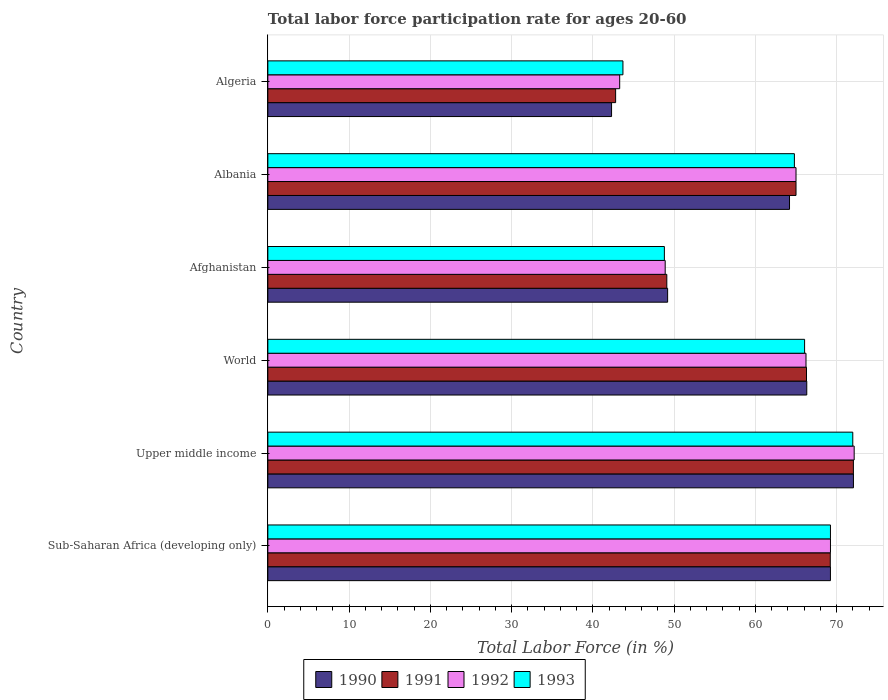How many bars are there on the 5th tick from the top?
Offer a very short reply. 4. How many bars are there on the 4th tick from the bottom?
Give a very brief answer. 4. In how many cases, is the number of bars for a given country not equal to the number of legend labels?
Your response must be concise. 0. What is the labor force participation rate in 1990 in World?
Ensure brevity in your answer.  66.32. Across all countries, what is the maximum labor force participation rate in 1993?
Your response must be concise. 71.98. Across all countries, what is the minimum labor force participation rate in 1991?
Ensure brevity in your answer.  42.8. In which country was the labor force participation rate in 1990 maximum?
Keep it short and to the point. Upper middle income. In which country was the labor force participation rate in 1990 minimum?
Your answer should be compact. Algeria. What is the total labor force participation rate in 1991 in the graph?
Provide a succinct answer. 364.47. What is the difference between the labor force participation rate in 1991 in Albania and that in Algeria?
Ensure brevity in your answer.  22.2. What is the difference between the labor force participation rate in 1992 in Albania and the labor force participation rate in 1993 in Afghanistan?
Ensure brevity in your answer.  16.2. What is the average labor force participation rate in 1993 per country?
Your answer should be very brief. 60.76. What is the difference between the labor force participation rate in 1990 and labor force participation rate in 1991 in Upper middle income?
Provide a short and direct response. 0.01. In how many countries, is the labor force participation rate in 1991 greater than 32 %?
Provide a succinct answer. 6. What is the ratio of the labor force participation rate in 1991 in Albania to that in Upper middle income?
Provide a short and direct response. 0.9. Is the difference between the labor force participation rate in 1990 in Sub-Saharan Africa (developing only) and World greater than the difference between the labor force participation rate in 1991 in Sub-Saharan Africa (developing only) and World?
Make the answer very short. No. What is the difference between the highest and the second highest labor force participation rate in 1993?
Provide a succinct answer. 2.75. What is the difference between the highest and the lowest labor force participation rate in 1990?
Ensure brevity in your answer.  29.77. Is it the case that in every country, the sum of the labor force participation rate in 1992 and labor force participation rate in 1990 is greater than the sum of labor force participation rate in 1993 and labor force participation rate in 1991?
Your answer should be compact. No. What does the 3rd bar from the bottom in World represents?
Your answer should be very brief. 1992. Is it the case that in every country, the sum of the labor force participation rate in 1990 and labor force participation rate in 1993 is greater than the labor force participation rate in 1992?
Offer a terse response. Yes. Are all the bars in the graph horizontal?
Provide a succinct answer. Yes. What is the difference between two consecutive major ticks on the X-axis?
Offer a very short reply. 10. Does the graph contain any zero values?
Offer a very short reply. No. Where does the legend appear in the graph?
Give a very brief answer. Bottom center. What is the title of the graph?
Your answer should be very brief. Total labor force participation rate for ages 20-60. What is the label or title of the X-axis?
Offer a very short reply. Total Labor Force (in %). What is the Total Labor Force (in %) in 1990 in Sub-Saharan Africa (developing only)?
Keep it short and to the point. 69.24. What is the Total Labor Force (in %) of 1991 in Sub-Saharan Africa (developing only)?
Give a very brief answer. 69.22. What is the Total Labor Force (in %) of 1992 in Sub-Saharan Africa (developing only)?
Keep it short and to the point. 69.24. What is the Total Labor Force (in %) of 1993 in Sub-Saharan Africa (developing only)?
Your answer should be very brief. 69.24. What is the Total Labor Force (in %) of 1990 in Upper middle income?
Give a very brief answer. 72.07. What is the Total Labor Force (in %) of 1991 in Upper middle income?
Give a very brief answer. 72.06. What is the Total Labor Force (in %) in 1992 in Upper middle income?
Offer a very short reply. 72.16. What is the Total Labor Force (in %) of 1993 in Upper middle income?
Ensure brevity in your answer.  71.98. What is the Total Labor Force (in %) of 1990 in World?
Your answer should be very brief. 66.32. What is the Total Labor Force (in %) in 1991 in World?
Provide a short and direct response. 66.29. What is the Total Labor Force (in %) of 1992 in World?
Your response must be concise. 66.23. What is the Total Labor Force (in %) in 1993 in World?
Your answer should be compact. 66.06. What is the Total Labor Force (in %) of 1990 in Afghanistan?
Offer a terse response. 49.2. What is the Total Labor Force (in %) of 1991 in Afghanistan?
Keep it short and to the point. 49.1. What is the Total Labor Force (in %) in 1992 in Afghanistan?
Offer a terse response. 48.9. What is the Total Labor Force (in %) of 1993 in Afghanistan?
Ensure brevity in your answer.  48.8. What is the Total Labor Force (in %) of 1990 in Albania?
Give a very brief answer. 64.2. What is the Total Labor Force (in %) in 1992 in Albania?
Offer a terse response. 65. What is the Total Labor Force (in %) of 1993 in Albania?
Offer a terse response. 64.8. What is the Total Labor Force (in %) of 1990 in Algeria?
Ensure brevity in your answer.  42.3. What is the Total Labor Force (in %) in 1991 in Algeria?
Ensure brevity in your answer.  42.8. What is the Total Labor Force (in %) in 1992 in Algeria?
Ensure brevity in your answer.  43.3. What is the Total Labor Force (in %) in 1993 in Algeria?
Offer a very short reply. 43.7. Across all countries, what is the maximum Total Labor Force (in %) in 1990?
Keep it short and to the point. 72.07. Across all countries, what is the maximum Total Labor Force (in %) in 1991?
Keep it short and to the point. 72.06. Across all countries, what is the maximum Total Labor Force (in %) of 1992?
Your response must be concise. 72.16. Across all countries, what is the maximum Total Labor Force (in %) in 1993?
Offer a very short reply. 71.98. Across all countries, what is the minimum Total Labor Force (in %) in 1990?
Ensure brevity in your answer.  42.3. Across all countries, what is the minimum Total Labor Force (in %) in 1991?
Offer a very short reply. 42.8. Across all countries, what is the minimum Total Labor Force (in %) in 1992?
Offer a very short reply. 43.3. Across all countries, what is the minimum Total Labor Force (in %) in 1993?
Make the answer very short. 43.7. What is the total Total Labor Force (in %) of 1990 in the graph?
Offer a very short reply. 363.33. What is the total Total Labor Force (in %) in 1991 in the graph?
Your answer should be compact. 364.47. What is the total Total Labor Force (in %) of 1992 in the graph?
Your response must be concise. 364.82. What is the total Total Labor Force (in %) of 1993 in the graph?
Ensure brevity in your answer.  364.58. What is the difference between the Total Labor Force (in %) of 1990 in Sub-Saharan Africa (developing only) and that in Upper middle income?
Your response must be concise. -2.83. What is the difference between the Total Labor Force (in %) in 1991 in Sub-Saharan Africa (developing only) and that in Upper middle income?
Offer a terse response. -2.84. What is the difference between the Total Labor Force (in %) in 1992 in Sub-Saharan Africa (developing only) and that in Upper middle income?
Ensure brevity in your answer.  -2.92. What is the difference between the Total Labor Force (in %) in 1993 in Sub-Saharan Africa (developing only) and that in Upper middle income?
Your answer should be very brief. -2.75. What is the difference between the Total Labor Force (in %) of 1990 in Sub-Saharan Africa (developing only) and that in World?
Offer a terse response. 2.91. What is the difference between the Total Labor Force (in %) in 1991 in Sub-Saharan Africa (developing only) and that in World?
Your response must be concise. 2.93. What is the difference between the Total Labor Force (in %) of 1992 in Sub-Saharan Africa (developing only) and that in World?
Give a very brief answer. 3.01. What is the difference between the Total Labor Force (in %) in 1993 in Sub-Saharan Africa (developing only) and that in World?
Offer a very short reply. 3.18. What is the difference between the Total Labor Force (in %) of 1990 in Sub-Saharan Africa (developing only) and that in Afghanistan?
Offer a terse response. 20.04. What is the difference between the Total Labor Force (in %) of 1991 in Sub-Saharan Africa (developing only) and that in Afghanistan?
Give a very brief answer. 20.12. What is the difference between the Total Labor Force (in %) in 1992 in Sub-Saharan Africa (developing only) and that in Afghanistan?
Offer a very short reply. 20.34. What is the difference between the Total Labor Force (in %) of 1993 in Sub-Saharan Africa (developing only) and that in Afghanistan?
Keep it short and to the point. 20.44. What is the difference between the Total Labor Force (in %) in 1990 in Sub-Saharan Africa (developing only) and that in Albania?
Give a very brief answer. 5.04. What is the difference between the Total Labor Force (in %) in 1991 in Sub-Saharan Africa (developing only) and that in Albania?
Ensure brevity in your answer.  4.22. What is the difference between the Total Labor Force (in %) of 1992 in Sub-Saharan Africa (developing only) and that in Albania?
Your answer should be compact. 4.24. What is the difference between the Total Labor Force (in %) in 1993 in Sub-Saharan Africa (developing only) and that in Albania?
Provide a succinct answer. 4.44. What is the difference between the Total Labor Force (in %) of 1990 in Sub-Saharan Africa (developing only) and that in Algeria?
Provide a short and direct response. 26.94. What is the difference between the Total Labor Force (in %) in 1991 in Sub-Saharan Africa (developing only) and that in Algeria?
Give a very brief answer. 26.42. What is the difference between the Total Labor Force (in %) in 1992 in Sub-Saharan Africa (developing only) and that in Algeria?
Ensure brevity in your answer.  25.94. What is the difference between the Total Labor Force (in %) of 1993 in Sub-Saharan Africa (developing only) and that in Algeria?
Offer a terse response. 25.54. What is the difference between the Total Labor Force (in %) of 1990 in Upper middle income and that in World?
Ensure brevity in your answer.  5.74. What is the difference between the Total Labor Force (in %) in 1991 in Upper middle income and that in World?
Your answer should be compact. 5.77. What is the difference between the Total Labor Force (in %) in 1992 in Upper middle income and that in World?
Your answer should be compact. 5.93. What is the difference between the Total Labor Force (in %) in 1993 in Upper middle income and that in World?
Your answer should be very brief. 5.93. What is the difference between the Total Labor Force (in %) in 1990 in Upper middle income and that in Afghanistan?
Your answer should be compact. 22.87. What is the difference between the Total Labor Force (in %) in 1991 in Upper middle income and that in Afghanistan?
Your response must be concise. 22.96. What is the difference between the Total Labor Force (in %) of 1992 in Upper middle income and that in Afghanistan?
Keep it short and to the point. 23.26. What is the difference between the Total Labor Force (in %) of 1993 in Upper middle income and that in Afghanistan?
Ensure brevity in your answer.  23.18. What is the difference between the Total Labor Force (in %) in 1990 in Upper middle income and that in Albania?
Your response must be concise. 7.87. What is the difference between the Total Labor Force (in %) of 1991 in Upper middle income and that in Albania?
Offer a terse response. 7.06. What is the difference between the Total Labor Force (in %) in 1992 in Upper middle income and that in Albania?
Make the answer very short. 7.16. What is the difference between the Total Labor Force (in %) in 1993 in Upper middle income and that in Albania?
Offer a terse response. 7.18. What is the difference between the Total Labor Force (in %) in 1990 in Upper middle income and that in Algeria?
Keep it short and to the point. 29.77. What is the difference between the Total Labor Force (in %) in 1991 in Upper middle income and that in Algeria?
Offer a very short reply. 29.26. What is the difference between the Total Labor Force (in %) in 1992 in Upper middle income and that in Algeria?
Your response must be concise. 28.86. What is the difference between the Total Labor Force (in %) of 1993 in Upper middle income and that in Algeria?
Provide a short and direct response. 28.28. What is the difference between the Total Labor Force (in %) of 1990 in World and that in Afghanistan?
Provide a succinct answer. 17.12. What is the difference between the Total Labor Force (in %) of 1991 in World and that in Afghanistan?
Provide a short and direct response. 17.19. What is the difference between the Total Labor Force (in %) in 1992 in World and that in Afghanistan?
Provide a succinct answer. 17.33. What is the difference between the Total Labor Force (in %) in 1993 in World and that in Afghanistan?
Make the answer very short. 17.26. What is the difference between the Total Labor Force (in %) in 1990 in World and that in Albania?
Your response must be concise. 2.12. What is the difference between the Total Labor Force (in %) of 1991 in World and that in Albania?
Offer a very short reply. 1.29. What is the difference between the Total Labor Force (in %) in 1992 in World and that in Albania?
Keep it short and to the point. 1.23. What is the difference between the Total Labor Force (in %) in 1993 in World and that in Albania?
Ensure brevity in your answer.  1.26. What is the difference between the Total Labor Force (in %) of 1990 in World and that in Algeria?
Make the answer very short. 24.02. What is the difference between the Total Labor Force (in %) in 1991 in World and that in Algeria?
Your answer should be very brief. 23.49. What is the difference between the Total Labor Force (in %) in 1992 in World and that in Algeria?
Offer a very short reply. 22.93. What is the difference between the Total Labor Force (in %) of 1993 in World and that in Algeria?
Your answer should be very brief. 22.36. What is the difference between the Total Labor Force (in %) in 1991 in Afghanistan and that in Albania?
Your answer should be compact. -15.9. What is the difference between the Total Labor Force (in %) in 1992 in Afghanistan and that in Albania?
Offer a terse response. -16.1. What is the difference between the Total Labor Force (in %) in 1990 in Afghanistan and that in Algeria?
Offer a very short reply. 6.9. What is the difference between the Total Labor Force (in %) of 1992 in Afghanistan and that in Algeria?
Your response must be concise. 5.6. What is the difference between the Total Labor Force (in %) of 1993 in Afghanistan and that in Algeria?
Provide a succinct answer. 5.1. What is the difference between the Total Labor Force (in %) of 1990 in Albania and that in Algeria?
Your answer should be compact. 21.9. What is the difference between the Total Labor Force (in %) of 1991 in Albania and that in Algeria?
Provide a succinct answer. 22.2. What is the difference between the Total Labor Force (in %) of 1992 in Albania and that in Algeria?
Offer a terse response. 21.7. What is the difference between the Total Labor Force (in %) in 1993 in Albania and that in Algeria?
Your answer should be compact. 21.1. What is the difference between the Total Labor Force (in %) of 1990 in Sub-Saharan Africa (developing only) and the Total Labor Force (in %) of 1991 in Upper middle income?
Your response must be concise. -2.82. What is the difference between the Total Labor Force (in %) in 1990 in Sub-Saharan Africa (developing only) and the Total Labor Force (in %) in 1992 in Upper middle income?
Ensure brevity in your answer.  -2.92. What is the difference between the Total Labor Force (in %) in 1990 in Sub-Saharan Africa (developing only) and the Total Labor Force (in %) in 1993 in Upper middle income?
Make the answer very short. -2.75. What is the difference between the Total Labor Force (in %) in 1991 in Sub-Saharan Africa (developing only) and the Total Labor Force (in %) in 1992 in Upper middle income?
Your answer should be compact. -2.94. What is the difference between the Total Labor Force (in %) in 1991 in Sub-Saharan Africa (developing only) and the Total Labor Force (in %) in 1993 in Upper middle income?
Offer a terse response. -2.77. What is the difference between the Total Labor Force (in %) of 1992 in Sub-Saharan Africa (developing only) and the Total Labor Force (in %) of 1993 in Upper middle income?
Your response must be concise. -2.75. What is the difference between the Total Labor Force (in %) of 1990 in Sub-Saharan Africa (developing only) and the Total Labor Force (in %) of 1991 in World?
Ensure brevity in your answer.  2.95. What is the difference between the Total Labor Force (in %) in 1990 in Sub-Saharan Africa (developing only) and the Total Labor Force (in %) in 1992 in World?
Keep it short and to the point. 3.01. What is the difference between the Total Labor Force (in %) in 1990 in Sub-Saharan Africa (developing only) and the Total Labor Force (in %) in 1993 in World?
Your answer should be compact. 3.18. What is the difference between the Total Labor Force (in %) of 1991 in Sub-Saharan Africa (developing only) and the Total Labor Force (in %) of 1992 in World?
Offer a very short reply. 2.99. What is the difference between the Total Labor Force (in %) of 1991 in Sub-Saharan Africa (developing only) and the Total Labor Force (in %) of 1993 in World?
Offer a very short reply. 3.16. What is the difference between the Total Labor Force (in %) of 1992 in Sub-Saharan Africa (developing only) and the Total Labor Force (in %) of 1993 in World?
Give a very brief answer. 3.18. What is the difference between the Total Labor Force (in %) of 1990 in Sub-Saharan Africa (developing only) and the Total Labor Force (in %) of 1991 in Afghanistan?
Your answer should be compact. 20.14. What is the difference between the Total Labor Force (in %) of 1990 in Sub-Saharan Africa (developing only) and the Total Labor Force (in %) of 1992 in Afghanistan?
Your response must be concise. 20.34. What is the difference between the Total Labor Force (in %) of 1990 in Sub-Saharan Africa (developing only) and the Total Labor Force (in %) of 1993 in Afghanistan?
Give a very brief answer. 20.44. What is the difference between the Total Labor Force (in %) in 1991 in Sub-Saharan Africa (developing only) and the Total Labor Force (in %) in 1992 in Afghanistan?
Offer a very short reply. 20.32. What is the difference between the Total Labor Force (in %) of 1991 in Sub-Saharan Africa (developing only) and the Total Labor Force (in %) of 1993 in Afghanistan?
Your answer should be compact. 20.42. What is the difference between the Total Labor Force (in %) in 1992 in Sub-Saharan Africa (developing only) and the Total Labor Force (in %) in 1993 in Afghanistan?
Offer a terse response. 20.44. What is the difference between the Total Labor Force (in %) of 1990 in Sub-Saharan Africa (developing only) and the Total Labor Force (in %) of 1991 in Albania?
Provide a succinct answer. 4.24. What is the difference between the Total Labor Force (in %) in 1990 in Sub-Saharan Africa (developing only) and the Total Labor Force (in %) in 1992 in Albania?
Keep it short and to the point. 4.24. What is the difference between the Total Labor Force (in %) in 1990 in Sub-Saharan Africa (developing only) and the Total Labor Force (in %) in 1993 in Albania?
Ensure brevity in your answer.  4.44. What is the difference between the Total Labor Force (in %) in 1991 in Sub-Saharan Africa (developing only) and the Total Labor Force (in %) in 1992 in Albania?
Make the answer very short. 4.22. What is the difference between the Total Labor Force (in %) in 1991 in Sub-Saharan Africa (developing only) and the Total Labor Force (in %) in 1993 in Albania?
Provide a short and direct response. 4.42. What is the difference between the Total Labor Force (in %) of 1992 in Sub-Saharan Africa (developing only) and the Total Labor Force (in %) of 1993 in Albania?
Offer a very short reply. 4.44. What is the difference between the Total Labor Force (in %) of 1990 in Sub-Saharan Africa (developing only) and the Total Labor Force (in %) of 1991 in Algeria?
Make the answer very short. 26.44. What is the difference between the Total Labor Force (in %) in 1990 in Sub-Saharan Africa (developing only) and the Total Labor Force (in %) in 1992 in Algeria?
Your answer should be very brief. 25.94. What is the difference between the Total Labor Force (in %) in 1990 in Sub-Saharan Africa (developing only) and the Total Labor Force (in %) in 1993 in Algeria?
Your answer should be very brief. 25.54. What is the difference between the Total Labor Force (in %) in 1991 in Sub-Saharan Africa (developing only) and the Total Labor Force (in %) in 1992 in Algeria?
Keep it short and to the point. 25.92. What is the difference between the Total Labor Force (in %) in 1991 in Sub-Saharan Africa (developing only) and the Total Labor Force (in %) in 1993 in Algeria?
Your answer should be very brief. 25.52. What is the difference between the Total Labor Force (in %) of 1992 in Sub-Saharan Africa (developing only) and the Total Labor Force (in %) of 1993 in Algeria?
Give a very brief answer. 25.54. What is the difference between the Total Labor Force (in %) of 1990 in Upper middle income and the Total Labor Force (in %) of 1991 in World?
Provide a short and direct response. 5.78. What is the difference between the Total Labor Force (in %) in 1990 in Upper middle income and the Total Labor Force (in %) in 1992 in World?
Give a very brief answer. 5.84. What is the difference between the Total Labor Force (in %) in 1990 in Upper middle income and the Total Labor Force (in %) in 1993 in World?
Make the answer very short. 6.01. What is the difference between the Total Labor Force (in %) of 1991 in Upper middle income and the Total Labor Force (in %) of 1992 in World?
Give a very brief answer. 5.83. What is the difference between the Total Labor Force (in %) of 1991 in Upper middle income and the Total Labor Force (in %) of 1993 in World?
Your answer should be compact. 6. What is the difference between the Total Labor Force (in %) of 1992 in Upper middle income and the Total Labor Force (in %) of 1993 in World?
Offer a terse response. 6.1. What is the difference between the Total Labor Force (in %) of 1990 in Upper middle income and the Total Labor Force (in %) of 1991 in Afghanistan?
Provide a short and direct response. 22.97. What is the difference between the Total Labor Force (in %) of 1990 in Upper middle income and the Total Labor Force (in %) of 1992 in Afghanistan?
Your answer should be very brief. 23.17. What is the difference between the Total Labor Force (in %) of 1990 in Upper middle income and the Total Labor Force (in %) of 1993 in Afghanistan?
Keep it short and to the point. 23.27. What is the difference between the Total Labor Force (in %) in 1991 in Upper middle income and the Total Labor Force (in %) in 1992 in Afghanistan?
Make the answer very short. 23.16. What is the difference between the Total Labor Force (in %) of 1991 in Upper middle income and the Total Labor Force (in %) of 1993 in Afghanistan?
Your answer should be very brief. 23.26. What is the difference between the Total Labor Force (in %) of 1992 in Upper middle income and the Total Labor Force (in %) of 1993 in Afghanistan?
Give a very brief answer. 23.36. What is the difference between the Total Labor Force (in %) in 1990 in Upper middle income and the Total Labor Force (in %) in 1991 in Albania?
Your answer should be compact. 7.07. What is the difference between the Total Labor Force (in %) of 1990 in Upper middle income and the Total Labor Force (in %) of 1992 in Albania?
Offer a very short reply. 7.07. What is the difference between the Total Labor Force (in %) of 1990 in Upper middle income and the Total Labor Force (in %) of 1993 in Albania?
Your answer should be compact. 7.27. What is the difference between the Total Labor Force (in %) in 1991 in Upper middle income and the Total Labor Force (in %) in 1992 in Albania?
Ensure brevity in your answer.  7.06. What is the difference between the Total Labor Force (in %) in 1991 in Upper middle income and the Total Labor Force (in %) in 1993 in Albania?
Ensure brevity in your answer.  7.26. What is the difference between the Total Labor Force (in %) of 1992 in Upper middle income and the Total Labor Force (in %) of 1993 in Albania?
Your response must be concise. 7.36. What is the difference between the Total Labor Force (in %) of 1990 in Upper middle income and the Total Labor Force (in %) of 1991 in Algeria?
Make the answer very short. 29.27. What is the difference between the Total Labor Force (in %) in 1990 in Upper middle income and the Total Labor Force (in %) in 1992 in Algeria?
Keep it short and to the point. 28.77. What is the difference between the Total Labor Force (in %) of 1990 in Upper middle income and the Total Labor Force (in %) of 1993 in Algeria?
Offer a terse response. 28.37. What is the difference between the Total Labor Force (in %) in 1991 in Upper middle income and the Total Labor Force (in %) in 1992 in Algeria?
Your answer should be very brief. 28.76. What is the difference between the Total Labor Force (in %) in 1991 in Upper middle income and the Total Labor Force (in %) in 1993 in Algeria?
Offer a terse response. 28.36. What is the difference between the Total Labor Force (in %) of 1992 in Upper middle income and the Total Labor Force (in %) of 1993 in Algeria?
Keep it short and to the point. 28.46. What is the difference between the Total Labor Force (in %) in 1990 in World and the Total Labor Force (in %) in 1991 in Afghanistan?
Give a very brief answer. 17.22. What is the difference between the Total Labor Force (in %) in 1990 in World and the Total Labor Force (in %) in 1992 in Afghanistan?
Your answer should be compact. 17.42. What is the difference between the Total Labor Force (in %) in 1990 in World and the Total Labor Force (in %) in 1993 in Afghanistan?
Provide a short and direct response. 17.52. What is the difference between the Total Labor Force (in %) of 1991 in World and the Total Labor Force (in %) of 1992 in Afghanistan?
Give a very brief answer. 17.39. What is the difference between the Total Labor Force (in %) in 1991 in World and the Total Labor Force (in %) in 1993 in Afghanistan?
Offer a very short reply. 17.49. What is the difference between the Total Labor Force (in %) of 1992 in World and the Total Labor Force (in %) of 1993 in Afghanistan?
Your response must be concise. 17.43. What is the difference between the Total Labor Force (in %) of 1990 in World and the Total Labor Force (in %) of 1991 in Albania?
Offer a terse response. 1.32. What is the difference between the Total Labor Force (in %) in 1990 in World and the Total Labor Force (in %) in 1992 in Albania?
Provide a short and direct response. 1.32. What is the difference between the Total Labor Force (in %) in 1990 in World and the Total Labor Force (in %) in 1993 in Albania?
Offer a terse response. 1.52. What is the difference between the Total Labor Force (in %) in 1991 in World and the Total Labor Force (in %) in 1992 in Albania?
Offer a terse response. 1.29. What is the difference between the Total Labor Force (in %) in 1991 in World and the Total Labor Force (in %) in 1993 in Albania?
Make the answer very short. 1.49. What is the difference between the Total Labor Force (in %) in 1992 in World and the Total Labor Force (in %) in 1993 in Albania?
Keep it short and to the point. 1.43. What is the difference between the Total Labor Force (in %) in 1990 in World and the Total Labor Force (in %) in 1991 in Algeria?
Offer a terse response. 23.52. What is the difference between the Total Labor Force (in %) in 1990 in World and the Total Labor Force (in %) in 1992 in Algeria?
Provide a succinct answer. 23.02. What is the difference between the Total Labor Force (in %) in 1990 in World and the Total Labor Force (in %) in 1993 in Algeria?
Provide a succinct answer. 22.62. What is the difference between the Total Labor Force (in %) in 1991 in World and the Total Labor Force (in %) in 1992 in Algeria?
Provide a succinct answer. 22.99. What is the difference between the Total Labor Force (in %) in 1991 in World and the Total Labor Force (in %) in 1993 in Algeria?
Provide a succinct answer. 22.59. What is the difference between the Total Labor Force (in %) in 1992 in World and the Total Labor Force (in %) in 1993 in Algeria?
Give a very brief answer. 22.53. What is the difference between the Total Labor Force (in %) of 1990 in Afghanistan and the Total Labor Force (in %) of 1991 in Albania?
Give a very brief answer. -15.8. What is the difference between the Total Labor Force (in %) in 1990 in Afghanistan and the Total Labor Force (in %) in 1992 in Albania?
Make the answer very short. -15.8. What is the difference between the Total Labor Force (in %) of 1990 in Afghanistan and the Total Labor Force (in %) of 1993 in Albania?
Offer a terse response. -15.6. What is the difference between the Total Labor Force (in %) in 1991 in Afghanistan and the Total Labor Force (in %) in 1992 in Albania?
Ensure brevity in your answer.  -15.9. What is the difference between the Total Labor Force (in %) of 1991 in Afghanistan and the Total Labor Force (in %) of 1993 in Albania?
Provide a short and direct response. -15.7. What is the difference between the Total Labor Force (in %) of 1992 in Afghanistan and the Total Labor Force (in %) of 1993 in Albania?
Keep it short and to the point. -15.9. What is the difference between the Total Labor Force (in %) in 1990 in Afghanistan and the Total Labor Force (in %) in 1993 in Algeria?
Keep it short and to the point. 5.5. What is the difference between the Total Labor Force (in %) in 1990 in Albania and the Total Labor Force (in %) in 1991 in Algeria?
Offer a terse response. 21.4. What is the difference between the Total Labor Force (in %) of 1990 in Albania and the Total Labor Force (in %) of 1992 in Algeria?
Your answer should be very brief. 20.9. What is the difference between the Total Labor Force (in %) of 1990 in Albania and the Total Labor Force (in %) of 1993 in Algeria?
Your answer should be compact. 20.5. What is the difference between the Total Labor Force (in %) of 1991 in Albania and the Total Labor Force (in %) of 1992 in Algeria?
Offer a terse response. 21.7. What is the difference between the Total Labor Force (in %) in 1991 in Albania and the Total Labor Force (in %) in 1993 in Algeria?
Offer a terse response. 21.3. What is the difference between the Total Labor Force (in %) of 1992 in Albania and the Total Labor Force (in %) of 1993 in Algeria?
Your answer should be compact. 21.3. What is the average Total Labor Force (in %) of 1990 per country?
Offer a terse response. 60.55. What is the average Total Labor Force (in %) in 1991 per country?
Your answer should be very brief. 60.74. What is the average Total Labor Force (in %) in 1992 per country?
Your answer should be very brief. 60.8. What is the average Total Labor Force (in %) of 1993 per country?
Ensure brevity in your answer.  60.76. What is the difference between the Total Labor Force (in %) in 1990 and Total Labor Force (in %) in 1991 in Sub-Saharan Africa (developing only)?
Provide a succinct answer. 0.02. What is the difference between the Total Labor Force (in %) of 1990 and Total Labor Force (in %) of 1992 in Sub-Saharan Africa (developing only)?
Your answer should be very brief. -0. What is the difference between the Total Labor Force (in %) of 1990 and Total Labor Force (in %) of 1993 in Sub-Saharan Africa (developing only)?
Offer a very short reply. -0. What is the difference between the Total Labor Force (in %) in 1991 and Total Labor Force (in %) in 1992 in Sub-Saharan Africa (developing only)?
Make the answer very short. -0.02. What is the difference between the Total Labor Force (in %) in 1991 and Total Labor Force (in %) in 1993 in Sub-Saharan Africa (developing only)?
Make the answer very short. -0.02. What is the difference between the Total Labor Force (in %) in 1992 and Total Labor Force (in %) in 1993 in Sub-Saharan Africa (developing only)?
Offer a terse response. 0. What is the difference between the Total Labor Force (in %) in 1990 and Total Labor Force (in %) in 1991 in Upper middle income?
Make the answer very short. 0.01. What is the difference between the Total Labor Force (in %) in 1990 and Total Labor Force (in %) in 1992 in Upper middle income?
Offer a very short reply. -0.09. What is the difference between the Total Labor Force (in %) in 1990 and Total Labor Force (in %) in 1993 in Upper middle income?
Your answer should be very brief. 0.08. What is the difference between the Total Labor Force (in %) in 1991 and Total Labor Force (in %) in 1992 in Upper middle income?
Your answer should be compact. -0.1. What is the difference between the Total Labor Force (in %) of 1991 and Total Labor Force (in %) of 1993 in Upper middle income?
Offer a very short reply. 0.08. What is the difference between the Total Labor Force (in %) in 1992 and Total Labor Force (in %) in 1993 in Upper middle income?
Provide a succinct answer. 0.17. What is the difference between the Total Labor Force (in %) of 1990 and Total Labor Force (in %) of 1991 in World?
Keep it short and to the point. 0.03. What is the difference between the Total Labor Force (in %) of 1990 and Total Labor Force (in %) of 1992 in World?
Your answer should be compact. 0.09. What is the difference between the Total Labor Force (in %) in 1990 and Total Labor Force (in %) in 1993 in World?
Provide a short and direct response. 0.27. What is the difference between the Total Labor Force (in %) in 1991 and Total Labor Force (in %) in 1992 in World?
Your response must be concise. 0.06. What is the difference between the Total Labor Force (in %) of 1991 and Total Labor Force (in %) of 1993 in World?
Give a very brief answer. 0.23. What is the difference between the Total Labor Force (in %) of 1992 and Total Labor Force (in %) of 1993 in World?
Make the answer very short. 0.17. What is the difference between the Total Labor Force (in %) in 1990 and Total Labor Force (in %) in 1991 in Afghanistan?
Your answer should be very brief. 0.1. What is the difference between the Total Labor Force (in %) in 1990 and Total Labor Force (in %) in 1993 in Afghanistan?
Your answer should be compact. 0.4. What is the difference between the Total Labor Force (in %) of 1990 and Total Labor Force (in %) of 1993 in Albania?
Offer a terse response. -0.6. What is the difference between the Total Labor Force (in %) in 1991 and Total Labor Force (in %) in 1992 in Albania?
Offer a very short reply. 0. What is the difference between the Total Labor Force (in %) of 1990 and Total Labor Force (in %) of 1991 in Algeria?
Your answer should be very brief. -0.5. What is the difference between the Total Labor Force (in %) of 1990 and Total Labor Force (in %) of 1992 in Algeria?
Keep it short and to the point. -1. What is the difference between the Total Labor Force (in %) of 1991 and Total Labor Force (in %) of 1992 in Algeria?
Keep it short and to the point. -0.5. What is the ratio of the Total Labor Force (in %) of 1990 in Sub-Saharan Africa (developing only) to that in Upper middle income?
Provide a succinct answer. 0.96. What is the ratio of the Total Labor Force (in %) of 1991 in Sub-Saharan Africa (developing only) to that in Upper middle income?
Make the answer very short. 0.96. What is the ratio of the Total Labor Force (in %) of 1992 in Sub-Saharan Africa (developing only) to that in Upper middle income?
Your answer should be compact. 0.96. What is the ratio of the Total Labor Force (in %) of 1993 in Sub-Saharan Africa (developing only) to that in Upper middle income?
Your response must be concise. 0.96. What is the ratio of the Total Labor Force (in %) of 1990 in Sub-Saharan Africa (developing only) to that in World?
Your response must be concise. 1.04. What is the ratio of the Total Labor Force (in %) of 1991 in Sub-Saharan Africa (developing only) to that in World?
Your answer should be compact. 1.04. What is the ratio of the Total Labor Force (in %) in 1992 in Sub-Saharan Africa (developing only) to that in World?
Offer a terse response. 1.05. What is the ratio of the Total Labor Force (in %) of 1993 in Sub-Saharan Africa (developing only) to that in World?
Offer a terse response. 1.05. What is the ratio of the Total Labor Force (in %) of 1990 in Sub-Saharan Africa (developing only) to that in Afghanistan?
Provide a succinct answer. 1.41. What is the ratio of the Total Labor Force (in %) in 1991 in Sub-Saharan Africa (developing only) to that in Afghanistan?
Provide a succinct answer. 1.41. What is the ratio of the Total Labor Force (in %) of 1992 in Sub-Saharan Africa (developing only) to that in Afghanistan?
Give a very brief answer. 1.42. What is the ratio of the Total Labor Force (in %) in 1993 in Sub-Saharan Africa (developing only) to that in Afghanistan?
Your answer should be very brief. 1.42. What is the ratio of the Total Labor Force (in %) in 1990 in Sub-Saharan Africa (developing only) to that in Albania?
Provide a short and direct response. 1.08. What is the ratio of the Total Labor Force (in %) in 1991 in Sub-Saharan Africa (developing only) to that in Albania?
Make the answer very short. 1.06. What is the ratio of the Total Labor Force (in %) in 1992 in Sub-Saharan Africa (developing only) to that in Albania?
Your response must be concise. 1.07. What is the ratio of the Total Labor Force (in %) in 1993 in Sub-Saharan Africa (developing only) to that in Albania?
Offer a terse response. 1.07. What is the ratio of the Total Labor Force (in %) of 1990 in Sub-Saharan Africa (developing only) to that in Algeria?
Provide a succinct answer. 1.64. What is the ratio of the Total Labor Force (in %) in 1991 in Sub-Saharan Africa (developing only) to that in Algeria?
Provide a short and direct response. 1.62. What is the ratio of the Total Labor Force (in %) in 1992 in Sub-Saharan Africa (developing only) to that in Algeria?
Provide a short and direct response. 1.6. What is the ratio of the Total Labor Force (in %) in 1993 in Sub-Saharan Africa (developing only) to that in Algeria?
Give a very brief answer. 1.58. What is the ratio of the Total Labor Force (in %) in 1990 in Upper middle income to that in World?
Provide a short and direct response. 1.09. What is the ratio of the Total Labor Force (in %) of 1991 in Upper middle income to that in World?
Your answer should be compact. 1.09. What is the ratio of the Total Labor Force (in %) of 1992 in Upper middle income to that in World?
Keep it short and to the point. 1.09. What is the ratio of the Total Labor Force (in %) in 1993 in Upper middle income to that in World?
Make the answer very short. 1.09. What is the ratio of the Total Labor Force (in %) of 1990 in Upper middle income to that in Afghanistan?
Keep it short and to the point. 1.46. What is the ratio of the Total Labor Force (in %) of 1991 in Upper middle income to that in Afghanistan?
Make the answer very short. 1.47. What is the ratio of the Total Labor Force (in %) in 1992 in Upper middle income to that in Afghanistan?
Provide a short and direct response. 1.48. What is the ratio of the Total Labor Force (in %) in 1993 in Upper middle income to that in Afghanistan?
Provide a short and direct response. 1.48. What is the ratio of the Total Labor Force (in %) of 1990 in Upper middle income to that in Albania?
Your response must be concise. 1.12. What is the ratio of the Total Labor Force (in %) in 1991 in Upper middle income to that in Albania?
Give a very brief answer. 1.11. What is the ratio of the Total Labor Force (in %) of 1992 in Upper middle income to that in Albania?
Provide a short and direct response. 1.11. What is the ratio of the Total Labor Force (in %) of 1993 in Upper middle income to that in Albania?
Provide a succinct answer. 1.11. What is the ratio of the Total Labor Force (in %) in 1990 in Upper middle income to that in Algeria?
Provide a succinct answer. 1.7. What is the ratio of the Total Labor Force (in %) in 1991 in Upper middle income to that in Algeria?
Your answer should be compact. 1.68. What is the ratio of the Total Labor Force (in %) of 1992 in Upper middle income to that in Algeria?
Your response must be concise. 1.67. What is the ratio of the Total Labor Force (in %) of 1993 in Upper middle income to that in Algeria?
Make the answer very short. 1.65. What is the ratio of the Total Labor Force (in %) of 1990 in World to that in Afghanistan?
Ensure brevity in your answer.  1.35. What is the ratio of the Total Labor Force (in %) in 1991 in World to that in Afghanistan?
Your response must be concise. 1.35. What is the ratio of the Total Labor Force (in %) of 1992 in World to that in Afghanistan?
Offer a terse response. 1.35. What is the ratio of the Total Labor Force (in %) of 1993 in World to that in Afghanistan?
Your response must be concise. 1.35. What is the ratio of the Total Labor Force (in %) of 1990 in World to that in Albania?
Your answer should be very brief. 1.03. What is the ratio of the Total Labor Force (in %) of 1991 in World to that in Albania?
Offer a very short reply. 1.02. What is the ratio of the Total Labor Force (in %) of 1992 in World to that in Albania?
Give a very brief answer. 1.02. What is the ratio of the Total Labor Force (in %) in 1993 in World to that in Albania?
Keep it short and to the point. 1.02. What is the ratio of the Total Labor Force (in %) in 1990 in World to that in Algeria?
Ensure brevity in your answer.  1.57. What is the ratio of the Total Labor Force (in %) of 1991 in World to that in Algeria?
Give a very brief answer. 1.55. What is the ratio of the Total Labor Force (in %) in 1992 in World to that in Algeria?
Offer a very short reply. 1.53. What is the ratio of the Total Labor Force (in %) of 1993 in World to that in Algeria?
Your answer should be compact. 1.51. What is the ratio of the Total Labor Force (in %) of 1990 in Afghanistan to that in Albania?
Ensure brevity in your answer.  0.77. What is the ratio of the Total Labor Force (in %) in 1991 in Afghanistan to that in Albania?
Your response must be concise. 0.76. What is the ratio of the Total Labor Force (in %) in 1992 in Afghanistan to that in Albania?
Provide a short and direct response. 0.75. What is the ratio of the Total Labor Force (in %) of 1993 in Afghanistan to that in Albania?
Offer a very short reply. 0.75. What is the ratio of the Total Labor Force (in %) in 1990 in Afghanistan to that in Algeria?
Ensure brevity in your answer.  1.16. What is the ratio of the Total Labor Force (in %) in 1991 in Afghanistan to that in Algeria?
Ensure brevity in your answer.  1.15. What is the ratio of the Total Labor Force (in %) of 1992 in Afghanistan to that in Algeria?
Your answer should be compact. 1.13. What is the ratio of the Total Labor Force (in %) in 1993 in Afghanistan to that in Algeria?
Give a very brief answer. 1.12. What is the ratio of the Total Labor Force (in %) of 1990 in Albania to that in Algeria?
Provide a succinct answer. 1.52. What is the ratio of the Total Labor Force (in %) of 1991 in Albania to that in Algeria?
Offer a very short reply. 1.52. What is the ratio of the Total Labor Force (in %) of 1992 in Albania to that in Algeria?
Keep it short and to the point. 1.5. What is the ratio of the Total Labor Force (in %) of 1993 in Albania to that in Algeria?
Offer a very short reply. 1.48. What is the difference between the highest and the second highest Total Labor Force (in %) of 1990?
Your answer should be compact. 2.83. What is the difference between the highest and the second highest Total Labor Force (in %) of 1991?
Keep it short and to the point. 2.84. What is the difference between the highest and the second highest Total Labor Force (in %) in 1992?
Offer a terse response. 2.92. What is the difference between the highest and the second highest Total Labor Force (in %) in 1993?
Keep it short and to the point. 2.75. What is the difference between the highest and the lowest Total Labor Force (in %) of 1990?
Offer a very short reply. 29.77. What is the difference between the highest and the lowest Total Labor Force (in %) of 1991?
Offer a terse response. 29.26. What is the difference between the highest and the lowest Total Labor Force (in %) in 1992?
Offer a terse response. 28.86. What is the difference between the highest and the lowest Total Labor Force (in %) in 1993?
Your answer should be compact. 28.28. 